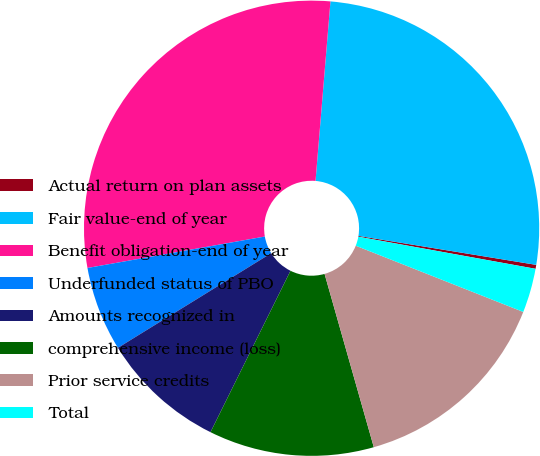Convert chart to OTSL. <chart><loc_0><loc_0><loc_500><loc_500><pie_chart><fcel>Actual return on plan assets<fcel>Fair value-end of year<fcel>Benefit obligation-end of year<fcel>Underfunded status of PBO<fcel>Amounts recognized in<fcel>comprehensive income (loss)<fcel>Prior service credits<fcel>Total<nl><fcel>0.28%<fcel>26.25%<fcel>29.11%<fcel>6.01%<fcel>8.87%<fcel>11.73%<fcel>14.6%<fcel>3.14%<nl></chart> 